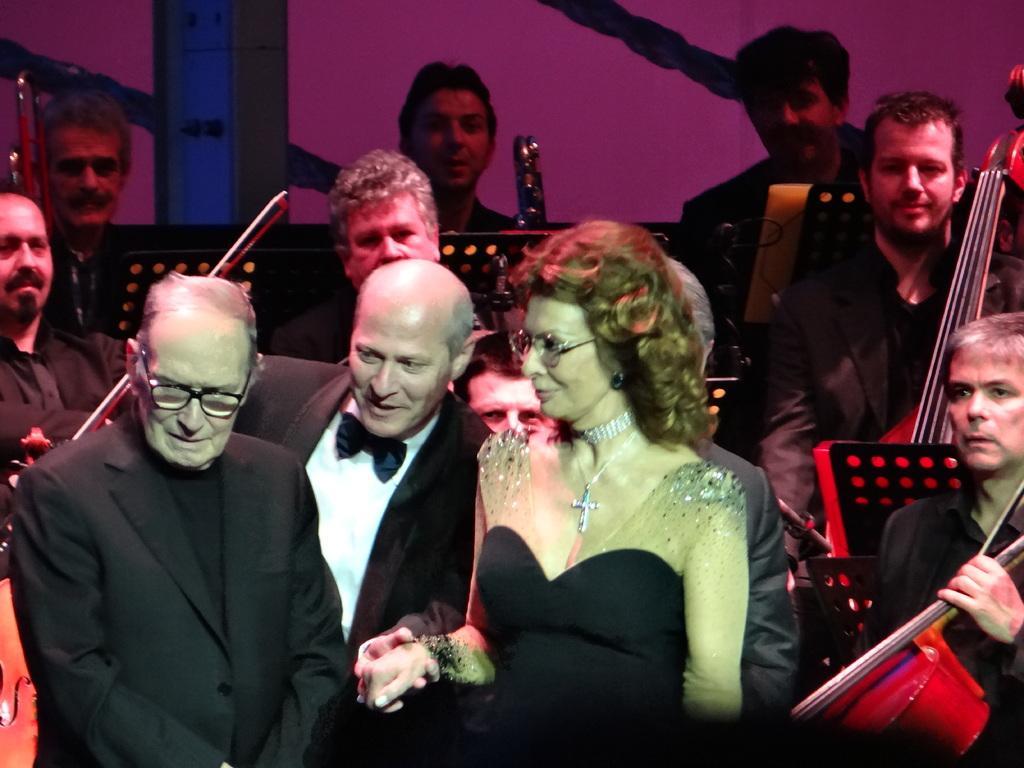Could you give a brief overview of what you see in this image? In this picture there are group of people who are holding musical instruments. There is a woman standing in the middle. 